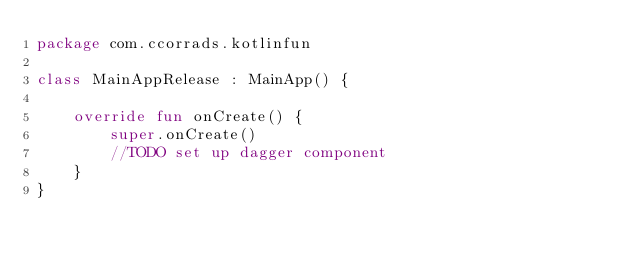<code> <loc_0><loc_0><loc_500><loc_500><_Kotlin_>package com.ccorrads.kotlinfun

class MainAppRelease : MainApp() {

    override fun onCreate() {
        super.onCreate()
        //TODO set up dagger component
    }
}</code> 